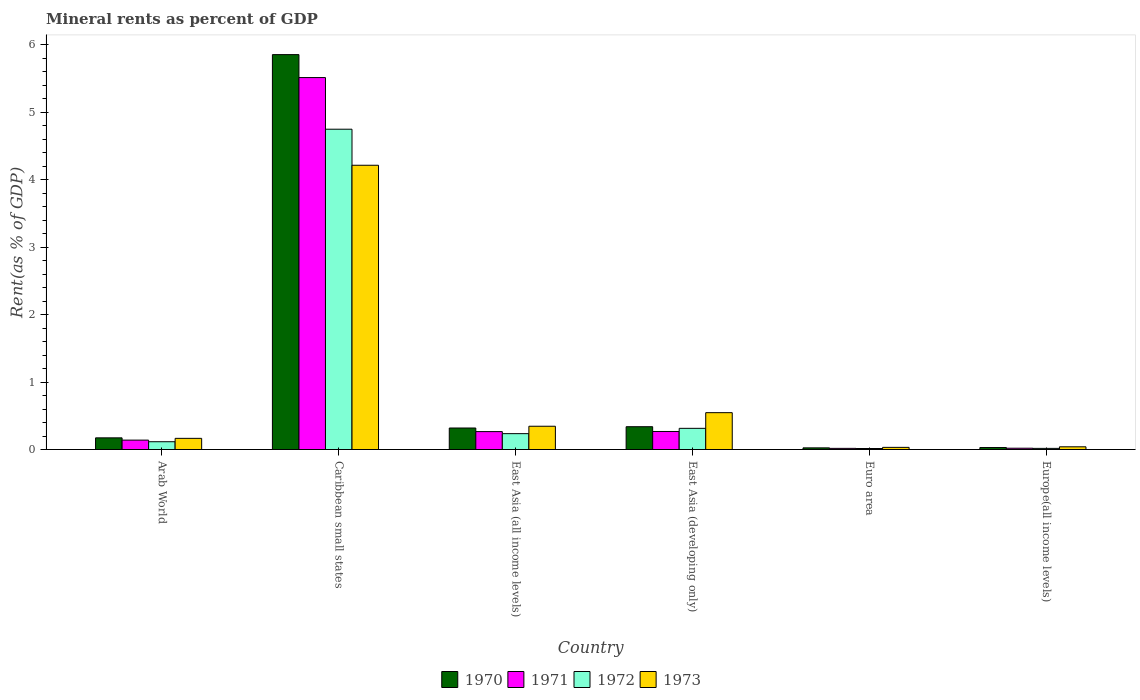Are the number of bars per tick equal to the number of legend labels?
Offer a very short reply. Yes. How many bars are there on the 2nd tick from the right?
Offer a very short reply. 4. What is the label of the 2nd group of bars from the left?
Offer a very short reply. Caribbean small states. In how many cases, is the number of bars for a given country not equal to the number of legend labels?
Your answer should be compact. 0. What is the mineral rent in 1970 in East Asia (developing only)?
Provide a short and direct response. 0.34. Across all countries, what is the maximum mineral rent in 1970?
Ensure brevity in your answer.  5.86. Across all countries, what is the minimum mineral rent in 1973?
Provide a succinct answer. 0.03. In which country was the mineral rent in 1970 maximum?
Your answer should be compact. Caribbean small states. What is the total mineral rent in 1970 in the graph?
Ensure brevity in your answer.  6.74. What is the difference between the mineral rent in 1973 in East Asia (developing only) and that in Euro area?
Offer a terse response. 0.51. What is the difference between the mineral rent in 1973 in East Asia (all income levels) and the mineral rent in 1971 in Arab World?
Offer a very short reply. 0.21. What is the average mineral rent in 1970 per country?
Your answer should be very brief. 1.12. What is the difference between the mineral rent of/in 1971 and mineral rent of/in 1973 in Arab World?
Your response must be concise. -0.03. What is the ratio of the mineral rent in 1972 in Arab World to that in East Asia (developing only)?
Provide a succinct answer. 0.37. Is the mineral rent in 1971 in East Asia (all income levels) less than that in Euro area?
Provide a succinct answer. No. What is the difference between the highest and the second highest mineral rent in 1971?
Give a very brief answer. -5.25. What is the difference between the highest and the lowest mineral rent in 1972?
Provide a short and direct response. 4.74. In how many countries, is the mineral rent in 1973 greater than the average mineral rent in 1973 taken over all countries?
Make the answer very short. 1. Is the sum of the mineral rent in 1970 in Caribbean small states and East Asia (all income levels) greater than the maximum mineral rent in 1973 across all countries?
Make the answer very short. Yes. Is it the case that in every country, the sum of the mineral rent in 1972 and mineral rent in 1973 is greater than the sum of mineral rent in 1971 and mineral rent in 1970?
Offer a very short reply. No. What does the 1st bar from the left in Euro area represents?
Offer a terse response. 1970. Is it the case that in every country, the sum of the mineral rent in 1973 and mineral rent in 1970 is greater than the mineral rent in 1972?
Give a very brief answer. Yes. How many countries are there in the graph?
Keep it short and to the point. 6. What is the difference between two consecutive major ticks on the Y-axis?
Offer a terse response. 1. Does the graph contain grids?
Your answer should be very brief. No. How many legend labels are there?
Offer a very short reply. 4. What is the title of the graph?
Provide a succinct answer. Mineral rents as percent of GDP. Does "1971" appear as one of the legend labels in the graph?
Give a very brief answer. Yes. What is the label or title of the Y-axis?
Offer a very short reply. Rent(as % of GDP). What is the Rent(as % of GDP) in 1970 in Arab World?
Your answer should be compact. 0.17. What is the Rent(as % of GDP) in 1971 in Arab World?
Your response must be concise. 0.14. What is the Rent(as % of GDP) in 1972 in Arab World?
Keep it short and to the point. 0.12. What is the Rent(as % of GDP) in 1973 in Arab World?
Provide a succinct answer. 0.17. What is the Rent(as % of GDP) in 1970 in Caribbean small states?
Make the answer very short. 5.86. What is the Rent(as % of GDP) of 1971 in Caribbean small states?
Ensure brevity in your answer.  5.52. What is the Rent(as % of GDP) in 1972 in Caribbean small states?
Offer a terse response. 4.75. What is the Rent(as % of GDP) of 1973 in Caribbean small states?
Provide a short and direct response. 4.22. What is the Rent(as % of GDP) of 1970 in East Asia (all income levels)?
Your answer should be very brief. 0.32. What is the Rent(as % of GDP) of 1971 in East Asia (all income levels)?
Your answer should be very brief. 0.27. What is the Rent(as % of GDP) of 1972 in East Asia (all income levels)?
Make the answer very short. 0.24. What is the Rent(as % of GDP) in 1973 in East Asia (all income levels)?
Keep it short and to the point. 0.35. What is the Rent(as % of GDP) in 1970 in East Asia (developing only)?
Your answer should be compact. 0.34. What is the Rent(as % of GDP) of 1971 in East Asia (developing only)?
Provide a short and direct response. 0.27. What is the Rent(as % of GDP) of 1972 in East Asia (developing only)?
Provide a short and direct response. 0.31. What is the Rent(as % of GDP) of 1973 in East Asia (developing only)?
Ensure brevity in your answer.  0.55. What is the Rent(as % of GDP) in 1970 in Euro area?
Keep it short and to the point. 0.02. What is the Rent(as % of GDP) in 1971 in Euro area?
Make the answer very short. 0.02. What is the Rent(as % of GDP) in 1972 in Euro area?
Provide a succinct answer. 0.02. What is the Rent(as % of GDP) of 1973 in Euro area?
Offer a very short reply. 0.03. What is the Rent(as % of GDP) in 1970 in Europe(all income levels)?
Your response must be concise. 0.03. What is the Rent(as % of GDP) in 1971 in Europe(all income levels)?
Ensure brevity in your answer.  0.02. What is the Rent(as % of GDP) of 1972 in Europe(all income levels)?
Your answer should be compact. 0.02. What is the Rent(as % of GDP) in 1973 in Europe(all income levels)?
Provide a short and direct response. 0.04. Across all countries, what is the maximum Rent(as % of GDP) in 1970?
Keep it short and to the point. 5.86. Across all countries, what is the maximum Rent(as % of GDP) of 1971?
Keep it short and to the point. 5.52. Across all countries, what is the maximum Rent(as % of GDP) of 1972?
Your answer should be compact. 4.75. Across all countries, what is the maximum Rent(as % of GDP) of 1973?
Provide a short and direct response. 4.22. Across all countries, what is the minimum Rent(as % of GDP) of 1970?
Provide a short and direct response. 0.02. Across all countries, what is the minimum Rent(as % of GDP) in 1971?
Your answer should be compact. 0.02. Across all countries, what is the minimum Rent(as % of GDP) in 1972?
Offer a terse response. 0.02. Across all countries, what is the minimum Rent(as % of GDP) in 1973?
Your response must be concise. 0.03. What is the total Rent(as % of GDP) in 1970 in the graph?
Provide a short and direct response. 6.74. What is the total Rent(as % of GDP) in 1971 in the graph?
Ensure brevity in your answer.  6.23. What is the total Rent(as % of GDP) of 1972 in the graph?
Make the answer very short. 5.45. What is the total Rent(as % of GDP) in 1973 in the graph?
Offer a terse response. 5.35. What is the difference between the Rent(as % of GDP) in 1970 in Arab World and that in Caribbean small states?
Ensure brevity in your answer.  -5.68. What is the difference between the Rent(as % of GDP) in 1971 in Arab World and that in Caribbean small states?
Provide a short and direct response. -5.38. What is the difference between the Rent(as % of GDP) of 1972 in Arab World and that in Caribbean small states?
Keep it short and to the point. -4.63. What is the difference between the Rent(as % of GDP) in 1973 in Arab World and that in Caribbean small states?
Your answer should be very brief. -4.05. What is the difference between the Rent(as % of GDP) of 1970 in Arab World and that in East Asia (all income levels)?
Your answer should be very brief. -0.15. What is the difference between the Rent(as % of GDP) of 1971 in Arab World and that in East Asia (all income levels)?
Offer a terse response. -0.13. What is the difference between the Rent(as % of GDP) of 1972 in Arab World and that in East Asia (all income levels)?
Your response must be concise. -0.12. What is the difference between the Rent(as % of GDP) of 1973 in Arab World and that in East Asia (all income levels)?
Keep it short and to the point. -0.18. What is the difference between the Rent(as % of GDP) in 1970 in Arab World and that in East Asia (developing only)?
Offer a very short reply. -0.17. What is the difference between the Rent(as % of GDP) of 1971 in Arab World and that in East Asia (developing only)?
Ensure brevity in your answer.  -0.13. What is the difference between the Rent(as % of GDP) in 1972 in Arab World and that in East Asia (developing only)?
Provide a short and direct response. -0.2. What is the difference between the Rent(as % of GDP) of 1973 in Arab World and that in East Asia (developing only)?
Provide a short and direct response. -0.38. What is the difference between the Rent(as % of GDP) of 1970 in Arab World and that in Euro area?
Keep it short and to the point. 0.15. What is the difference between the Rent(as % of GDP) of 1971 in Arab World and that in Euro area?
Keep it short and to the point. 0.12. What is the difference between the Rent(as % of GDP) in 1972 in Arab World and that in Euro area?
Keep it short and to the point. 0.1. What is the difference between the Rent(as % of GDP) of 1973 in Arab World and that in Euro area?
Ensure brevity in your answer.  0.13. What is the difference between the Rent(as % of GDP) of 1970 in Arab World and that in Europe(all income levels)?
Your answer should be compact. 0.14. What is the difference between the Rent(as % of GDP) in 1971 in Arab World and that in Europe(all income levels)?
Your answer should be very brief. 0.12. What is the difference between the Rent(as % of GDP) of 1972 in Arab World and that in Europe(all income levels)?
Ensure brevity in your answer.  0.1. What is the difference between the Rent(as % of GDP) of 1973 in Arab World and that in Europe(all income levels)?
Ensure brevity in your answer.  0.13. What is the difference between the Rent(as % of GDP) of 1970 in Caribbean small states and that in East Asia (all income levels)?
Offer a very short reply. 5.54. What is the difference between the Rent(as % of GDP) in 1971 in Caribbean small states and that in East Asia (all income levels)?
Provide a short and direct response. 5.25. What is the difference between the Rent(as % of GDP) in 1972 in Caribbean small states and that in East Asia (all income levels)?
Offer a very short reply. 4.51. What is the difference between the Rent(as % of GDP) in 1973 in Caribbean small states and that in East Asia (all income levels)?
Ensure brevity in your answer.  3.87. What is the difference between the Rent(as % of GDP) in 1970 in Caribbean small states and that in East Asia (developing only)?
Provide a short and direct response. 5.52. What is the difference between the Rent(as % of GDP) in 1971 in Caribbean small states and that in East Asia (developing only)?
Your answer should be compact. 5.25. What is the difference between the Rent(as % of GDP) in 1972 in Caribbean small states and that in East Asia (developing only)?
Your answer should be very brief. 4.44. What is the difference between the Rent(as % of GDP) in 1973 in Caribbean small states and that in East Asia (developing only)?
Your response must be concise. 3.67. What is the difference between the Rent(as % of GDP) of 1970 in Caribbean small states and that in Euro area?
Provide a succinct answer. 5.83. What is the difference between the Rent(as % of GDP) of 1971 in Caribbean small states and that in Euro area?
Keep it short and to the point. 5.5. What is the difference between the Rent(as % of GDP) of 1972 in Caribbean small states and that in Euro area?
Offer a terse response. 4.74. What is the difference between the Rent(as % of GDP) of 1973 in Caribbean small states and that in Euro area?
Your response must be concise. 4.18. What is the difference between the Rent(as % of GDP) of 1970 in Caribbean small states and that in Europe(all income levels)?
Keep it short and to the point. 5.83. What is the difference between the Rent(as % of GDP) in 1971 in Caribbean small states and that in Europe(all income levels)?
Your response must be concise. 5.5. What is the difference between the Rent(as % of GDP) in 1972 in Caribbean small states and that in Europe(all income levels)?
Make the answer very short. 4.73. What is the difference between the Rent(as % of GDP) in 1973 in Caribbean small states and that in Europe(all income levels)?
Give a very brief answer. 4.18. What is the difference between the Rent(as % of GDP) in 1970 in East Asia (all income levels) and that in East Asia (developing only)?
Make the answer very short. -0.02. What is the difference between the Rent(as % of GDP) of 1971 in East Asia (all income levels) and that in East Asia (developing only)?
Your response must be concise. -0. What is the difference between the Rent(as % of GDP) of 1972 in East Asia (all income levels) and that in East Asia (developing only)?
Provide a short and direct response. -0.08. What is the difference between the Rent(as % of GDP) in 1973 in East Asia (all income levels) and that in East Asia (developing only)?
Ensure brevity in your answer.  -0.2. What is the difference between the Rent(as % of GDP) in 1970 in East Asia (all income levels) and that in Euro area?
Make the answer very short. 0.29. What is the difference between the Rent(as % of GDP) in 1971 in East Asia (all income levels) and that in Euro area?
Make the answer very short. 0.25. What is the difference between the Rent(as % of GDP) in 1972 in East Asia (all income levels) and that in Euro area?
Make the answer very short. 0.22. What is the difference between the Rent(as % of GDP) in 1973 in East Asia (all income levels) and that in Euro area?
Ensure brevity in your answer.  0.31. What is the difference between the Rent(as % of GDP) of 1970 in East Asia (all income levels) and that in Europe(all income levels)?
Your answer should be compact. 0.29. What is the difference between the Rent(as % of GDP) in 1971 in East Asia (all income levels) and that in Europe(all income levels)?
Your answer should be compact. 0.25. What is the difference between the Rent(as % of GDP) of 1972 in East Asia (all income levels) and that in Europe(all income levels)?
Offer a terse response. 0.22. What is the difference between the Rent(as % of GDP) of 1973 in East Asia (all income levels) and that in Europe(all income levels)?
Offer a terse response. 0.3. What is the difference between the Rent(as % of GDP) of 1970 in East Asia (developing only) and that in Euro area?
Provide a succinct answer. 0.31. What is the difference between the Rent(as % of GDP) of 1971 in East Asia (developing only) and that in Euro area?
Ensure brevity in your answer.  0.25. What is the difference between the Rent(as % of GDP) of 1972 in East Asia (developing only) and that in Euro area?
Make the answer very short. 0.3. What is the difference between the Rent(as % of GDP) in 1973 in East Asia (developing only) and that in Euro area?
Offer a very short reply. 0.51. What is the difference between the Rent(as % of GDP) of 1970 in East Asia (developing only) and that in Europe(all income levels)?
Offer a very short reply. 0.31. What is the difference between the Rent(as % of GDP) in 1971 in East Asia (developing only) and that in Europe(all income levels)?
Keep it short and to the point. 0.25. What is the difference between the Rent(as % of GDP) in 1972 in East Asia (developing only) and that in Europe(all income levels)?
Ensure brevity in your answer.  0.3. What is the difference between the Rent(as % of GDP) in 1973 in East Asia (developing only) and that in Europe(all income levels)?
Make the answer very short. 0.51. What is the difference between the Rent(as % of GDP) of 1970 in Euro area and that in Europe(all income levels)?
Offer a terse response. -0. What is the difference between the Rent(as % of GDP) in 1971 in Euro area and that in Europe(all income levels)?
Give a very brief answer. -0. What is the difference between the Rent(as % of GDP) of 1972 in Euro area and that in Europe(all income levels)?
Give a very brief answer. -0. What is the difference between the Rent(as % of GDP) in 1973 in Euro area and that in Europe(all income levels)?
Ensure brevity in your answer.  -0.01. What is the difference between the Rent(as % of GDP) in 1970 in Arab World and the Rent(as % of GDP) in 1971 in Caribbean small states?
Provide a succinct answer. -5.34. What is the difference between the Rent(as % of GDP) in 1970 in Arab World and the Rent(as % of GDP) in 1972 in Caribbean small states?
Give a very brief answer. -4.58. What is the difference between the Rent(as % of GDP) in 1970 in Arab World and the Rent(as % of GDP) in 1973 in Caribbean small states?
Offer a terse response. -4.04. What is the difference between the Rent(as % of GDP) of 1971 in Arab World and the Rent(as % of GDP) of 1972 in Caribbean small states?
Offer a very short reply. -4.61. What is the difference between the Rent(as % of GDP) in 1971 in Arab World and the Rent(as % of GDP) in 1973 in Caribbean small states?
Offer a very short reply. -4.08. What is the difference between the Rent(as % of GDP) of 1972 in Arab World and the Rent(as % of GDP) of 1973 in Caribbean small states?
Your answer should be very brief. -4.1. What is the difference between the Rent(as % of GDP) of 1970 in Arab World and the Rent(as % of GDP) of 1971 in East Asia (all income levels)?
Provide a succinct answer. -0.09. What is the difference between the Rent(as % of GDP) of 1970 in Arab World and the Rent(as % of GDP) of 1972 in East Asia (all income levels)?
Give a very brief answer. -0.06. What is the difference between the Rent(as % of GDP) in 1970 in Arab World and the Rent(as % of GDP) in 1973 in East Asia (all income levels)?
Give a very brief answer. -0.17. What is the difference between the Rent(as % of GDP) of 1971 in Arab World and the Rent(as % of GDP) of 1972 in East Asia (all income levels)?
Your response must be concise. -0.1. What is the difference between the Rent(as % of GDP) in 1971 in Arab World and the Rent(as % of GDP) in 1973 in East Asia (all income levels)?
Offer a very short reply. -0.21. What is the difference between the Rent(as % of GDP) in 1972 in Arab World and the Rent(as % of GDP) in 1973 in East Asia (all income levels)?
Offer a very short reply. -0.23. What is the difference between the Rent(as % of GDP) of 1970 in Arab World and the Rent(as % of GDP) of 1971 in East Asia (developing only)?
Your response must be concise. -0.09. What is the difference between the Rent(as % of GDP) of 1970 in Arab World and the Rent(as % of GDP) of 1972 in East Asia (developing only)?
Provide a short and direct response. -0.14. What is the difference between the Rent(as % of GDP) in 1970 in Arab World and the Rent(as % of GDP) in 1973 in East Asia (developing only)?
Your response must be concise. -0.37. What is the difference between the Rent(as % of GDP) of 1971 in Arab World and the Rent(as % of GDP) of 1972 in East Asia (developing only)?
Offer a terse response. -0.17. What is the difference between the Rent(as % of GDP) in 1971 in Arab World and the Rent(as % of GDP) in 1973 in East Asia (developing only)?
Ensure brevity in your answer.  -0.41. What is the difference between the Rent(as % of GDP) in 1972 in Arab World and the Rent(as % of GDP) in 1973 in East Asia (developing only)?
Offer a terse response. -0.43. What is the difference between the Rent(as % of GDP) in 1970 in Arab World and the Rent(as % of GDP) in 1971 in Euro area?
Offer a terse response. 0.16. What is the difference between the Rent(as % of GDP) in 1970 in Arab World and the Rent(as % of GDP) in 1972 in Euro area?
Offer a terse response. 0.16. What is the difference between the Rent(as % of GDP) in 1970 in Arab World and the Rent(as % of GDP) in 1973 in Euro area?
Give a very brief answer. 0.14. What is the difference between the Rent(as % of GDP) in 1971 in Arab World and the Rent(as % of GDP) in 1972 in Euro area?
Offer a very short reply. 0.12. What is the difference between the Rent(as % of GDP) in 1971 in Arab World and the Rent(as % of GDP) in 1973 in Euro area?
Keep it short and to the point. 0.11. What is the difference between the Rent(as % of GDP) of 1972 in Arab World and the Rent(as % of GDP) of 1973 in Euro area?
Make the answer very short. 0.08. What is the difference between the Rent(as % of GDP) of 1970 in Arab World and the Rent(as % of GDP) of 1971 in Europe(all income levels)?
Give a very brief answer. 0.15. What is the difference between the Rent(as % of GDP) of 1970 in Arab World and the Rent(as % of GDP) of 1972 in Europe(all income levels)?
Ensure brevity in your answer.  0.16. What is the difference between the Rent(as % of GDP) in 1970 in Arab World and the Rent(as % of GDP) in 1973 in Europe(all income levels)?
Keep it short and to the point. 0.13. What is the difference between the Rent(as % of GDP) in 1971 in Arab World and the Rent(as % of GDP) in 1972 in Europe(all income levels)?
Keep it short and to the point. 0.12. What is the difference between the Rent(as % of GDP) in 1971 in Arab World and the Rent(as % of GDP) in 1973 in Europe(all income levels)?
Ensure brevity in your answer.  0.1. What is the difference between the Rent(as % of GDP) of 1972 in Arab World and the Rent(as % of GDP) of 1973 in Europe(all income levels)?
Keep it short and to the point. 0.08. What is the difference between the Rent(as % of GDP) of 1970 in Caribbean small states and the Rent(as % of GDP) of 1971 in East Asia (all income levels)?
Your response must be concise. 5.59. What is the difference between the Rent(as % of GDP) of 1970 in Caribbean small states and the Rent(as % of GDP) of 1972 in East Asia (all income levels)?
Your response must be concise. 5.62. What is the difference between the Rent(as % of GDP) of 1970 in Caribbean small states and the Rent(as % of GDP) of 1973 in East Asia (all income levels)?
Keep it short and to the point. 5.51. What is the difference between the Rent(as % of GDP) in 1971 in Caribbean small states and the Rent(as % of GDP) in 1972 in East Asia (all income levels)?
Offer a very short reply. 5.28. What is the difference between the Rent(as % of GDP) of 1971 in Caribbean small states and the Rent(as % of GDP) of 1973 in East Asia (all income levels)?
Give a very brief answer. 5.17. What is the difference between the Rent(as % of GDP) in 1972 in Caribbean small states and the Rent(as % of GDP) in 1973 in East Asia (all income levels)?
Keep it short and to the point. 4.41. What is the difference between the Rent(as % of GDP) of 1970 in Caribbean small states and the Rent(as % of GDP) of 1971 in East Asia (developing only)?
Your response must be concise. 5.59. What is the difference between the Rent(as % of GDP) in 1970 in Caribbean small states and the Rent(as % of GDP) in 1972 in East Asia (developing only)?
Provide a succinct answer. 5.54. What is the difference between the Rent(as % of GDP) in 1970 in Caribbean small states and the Rent(as % of GDP) in 1973 in East Asia (developing only)?
Provide a short and direct response. 5.31. What is the difference between the Rent(as % of GDP) of 1971 in Caribbean small states and the Rent(as % of GDP) of 1972 in East Asia (developing only)?
Your answer should be compact. 5.2. What is the difference between the Rent(as % of GDP) in 1971 in Caribbean small states and the Rent(as % of GDP) in 1973 in East Asia (developing only)?
Offer a very short reply. 4.97. What is the difference between the Rent(as % of GDP) of 1972 in Caribbean small states and the Rent(as % of GDP) of 1973 in East Asia (developing only)?
Offer a terse response. 4.2. What is the difference between the Rent(as % of GDP) of 1970 in Caribbean small states and the Rent(as % of GDP) of 1971 in Euro area?
Ensure brevity in your answer.  5.84. What is the difference between the Rent(as % of GDP) in 1970 in Caribbean small states and the Rent(as % of GDP) in 1972 in Euro area?
Your answer should be compact. 5.84. What is the difference between the Rent(as % of GDP) in 1970 in Caribbean small states and the Rent(as % of GDP) in 1973 in Euro area?
Make the answer very short. 5.82. What is the difference between the Rent(as % of GDP) of 1971 in Caribbean small states and the Rent(as % of GDP) of 1972 in Euro area?
Ensure brevity in your answer.  5.5. What is the difference between the Rent(as % of GDP) of 1971 in Caribbean small states and the Rent(as % of GDP) of 1973 in Euro area?
Offer a terse response. 5.48. What is the difference between the Rent(as % of GDP) in 1972 in Caribbean small states and the Rent(as % of GDP) in 1973 in Euro area?
Your answer should be very brief. 4.72. What is the difference between the Rent(as % of GDP) of 1970 in Caribbean small states and the Rent(as % of GDP) of 1971 in Europe(all income levels)?
Make the answer very short. 5.84. What is the difference between the Rent(as % of GDP) in 1970 in Caribbean small states and the Rent(as % of GDP) in 1972 in Europe(all income levels)?
Offer a terse response. 5.84. What is the difference between the Rent(as % of GDP) in 1970 in Caribbean small states and the Rent(as % of GDP) in 1973 in Europe(all income levels)?
Provide a short and direct response. 5.82. What is the difference between the Rent(as % of GDP) in 1971 in Caribbean small states and the Rent(as % of GDP) in 1972 in Europe(all income levels)?
Offer a terse response. 5.5. What is the difference between the Rent(as % of GDP) of 1971 in Caribbean small states and the Rent(as % of GDP) of 1973 in Europe(all income levels)?
Offer a terse response. 5.48. What is the difference between the Rent(as % of GDP) in 1972 in Caribbean small states and the Rent(as % of GDP) in 1973 in Europe(all income levels)?
Your response must be concise. 4.71. What is the difference between the Rent(as % of GDP) of 1970 in East Asia (all income levels) and the Rent(as % of GDP) of 1971 in East Asia (developing only)?
Provide a short and direct response. 0.05. What is the difference between the Rent(as % of GDP) in 1970 in East Asia (all income levels) and the Rent(as % of GDP) in 1972 in East Asia (developing only)?
Keep it short and to the point. 0. What is the difference between the Rent(as % of GDP) in 1970 in East Asia (all income levels) and the Rent(as % of GDP) in 1973 in East Asia (developing only)?
Make the answer very short. -0.23. What is the difference between the Rent(as % of GDP) of 1971 in East Asia (all income levels) and the Rent(as % of GDP) of 1972 in East Asia (developing only)?
Your answer should be very brief. -0.05. What is the difference between the Rent(as % of GDP) in 1971 in East Asia (all income levels) and the Rent(as % of GDP) in 1973 in East Asia (developing only)?
Provide a short and direct response. -0.28. What is the difference between the Rent(as % of GDP) of 1972 in East Asia (all income levels) and the Rent(as % of GDP) of 1973 in East Asia (developing only)?
Keep it short and to the point. -0.31. What is the difference between the Rent(as % of GDP) in 1970 in East Asia (all income levels) and the Rent(as % of GDP) in 1971 in Euro area?
Give a very brief answer. 0.3. What is the difference between the Rent(as % of GDP) in 1970 in East Asia (all income levels) and the Rent(as % of GDP) in 1972 in Euro area?
Ensure brevity in your answer.  0.3. What is the difference between the Rent(as % of GDP) of 1970 in East Asia (all income levels) and the Rent(as % of GDP) of 1973 in Euro area?
Make the answer very short. 0.29. What is the difference between the Rent(as % of GDP) of 1971 in East Asia (all income levels) and the Rent(as % of GDP) of 1972 in Euro area?
Offer a very short reply. 0.25. What is the difference between the Rent(as % of GDP) in 1971 in East Asia (all income levels) and the Rent(as % of GDP) in 1973 in Euro area?
Provide a short and direct response. 0.23. What is the difference between the Rent(as % of GDP) of 1972 in East Asia (all income levels) and the Rent(as % of GDP) of 1973 in Euro area?
Provide a short and direct response. 0.2. What is the difference between the Rent(as % of GDP) of 1970 in East Asia (all income levels) and the Rent(as % of GDP) of 1971 in Europe(all income levels)?
Provide a succinct answer. 0.3. What is the difference between the Rent(as % of GDP) of 1970 in East Asia (all income levels) and the Rent(as % of GDP) of 1972 in Europe(all income levels)?
Provide a succinct answer. 0.3. What is the difference between the Rent(as % of GDP) in 1970 in East Asia (all income levels) and the Rent(as % of GDP) in 1973 in Europe(all income levels)?
Your answer should be compact. 0.28. What is the difference between the Rent(as % of GDP) in 1971 in East Asia (all income levels) and the Rent(as % of GDP) in 1972 in Europe(all income levels)?
Provide a succinct answer. 0.25. What is the difference between the Rent(as % of GDP) in 1971 in East Asia (all income levels) and the Rent(as % of GDP) in 1973 in Europe(all income levels)?
Your answer should be compact. 0.23. What is the difference between the Rent(as % of GDP) in 1972 in East Asia (all income levels) and the Rent(as % of GDP) in 1973 in Europe(all income levels)?
Your answer should be very brief. 0.2. What is the difference between the Rent(as % of GDP) in 1970 in East Asia (developing only) and the Rent(as % of GDP) in 1971 in Euro area?
Offer a terse response. 0.32. What is the difference between the Rent(as % of GDP) of 1970 in East Asia (developing only) and the Rent(as % of GDP) of 1972 in Euro area?
Your answer should be compact. 0.32. What is the difference between the Rent(as % of GDP) in 1970 in East Asia (developing only) and the Rent(as % of GDP) in 1973 in Euro area?
Your answer should be compact. 0.31. What is the difference between the Rent(as % of GDP) in 1971 in East Asia (developing only) and the Rent(as % of GDP) in 1972 in Euro area?
Your answer should be compact. 0.25. What is the difference between the Rent(as % of GDP) of 1971 in East Asia (developing only) and the Rent(as % of GDP) of 1973 in Euro area?
Your answer should be compact. 0.24. What is the difference between the Rent(as % of GDP) of 1972 in East Asia (developing only) and the Rent(as % of GDP) of 1973 in Euro area?
Your answer should be compact. 0.28. What is the difference between the Rent(as % of GDP) in 1970 in East Asia (developing only) and the Rent(as % of GDP) in 1971 in Europe(all income levels)?
Offer a very short reply. 0.32. What is the difference between the Rent(as % of GDP) of 1970 in East Asia (developing only) and the Rent(as % of GDP) of 1972 in Europe(all income levels)?
Keep it short and to the point. 0.32. What is the difference between the Rent(as % of GDP) in 1970 in East Asia (developing only) and the Rent(as % of GDP) in 1973 in Europe(all income levels)?
Your response must be concise. 0.3. What is the difference between the Rent(as % of GDP) of 1971 in East Asia (developing only) and the Rent(as % of GDP) of 1972 in Europe(all income levels)?
Keep it short and to the point. 0.25. What is the difference between the Rent(as % of GDP) of 1971 in East Asia (developing only) and the Rent(as % of GDP) of 1973 in Europe(all income levels)?
Offer a terse response. 0.23. What is the difference between the Rent(as % of GDP) in 1972 in East Asia (developing only) and the Rent(as % of GDP) in 1973 in Europe(all income levels)?
Give a very brief answer. 0.27. What is the difference between the Rent(as % of GDP) in 1970 in Euro area and the Rent(as % of GDP) in 1971 in Europe(all income levels)?
Give a very brief answer. 0.01. What is the difference between the Rent(as % of GDP) of 1970 in Euro area and the Rent(as % of GDP) of 1972 in Europe(all income levels)?
Make the answer very short. 0.01. What is the difference between the Rent(as % of GDP) in 1970 in Euro area and the Rent(as % of GDP) in 1973 in Europe(all income levels)?
Keep it short and to the point. -0.02. What is the difference between the Rent(as % of GDP) of 1971 in Euro area and the Rent(as % of GDP) of 1973 in Europe(all income levels)?
Provide a succinct answer. -0.02. What is the difference between the Rent(as % of GDP) in 1972 in Euro area and the Rent(as % of GDP) in 1973 in Europe(all income levels)?
Give a very brief answer. -0.03. What is the average Rent(as % of GDP) of 1970 per country?
Keep it short and to the point. 1.12. What is the average Rent(as % of GDP) in 1971 per country?
Your answer should be very brief. 1.04. What is the average Rent(as % of GDP) of 1972 per country?
Your answer should be very brief. 0.91. What is the average Rent(as % of GDP) of 1973 per country?
Make the answer very short. 0.89. What is the difference between the Rent(as % of GDP) in 1970 and Rent(as % of GDP) in 1971 in Arab World?
Keep it short and to the point. 0.03. What is the difference between the Rent(as % of GDP) of 1970 and Rent(as % of GDP) of 1972 in Arab World?
Offer a very short reply. 0.06. What is the difference between the Rent(as % of GDP) of 1970 and Rent(as % of GDP) of 1973 in Arab World?
Your answer should be compact. 0.01. What is the difference between the Rent(as % of GDP) in 1971 and Rent(as % of GDP) in 1972 in Arab World?
Offer a terse response. 0.02. What is the difference between the Rent(as % of GDP) in 1971 and Rent(as % of GDP) in 1973 in Arab World?
Provide a short and direct response. -0.03. What is the difference between the Rent(as % of GDP) of 1972 and Rent(as % of GDP) of 1973 in Arab World?
Offer a very short reply. -0.05. What is the difference between the Rent(as % of GDP) of 1970 and Rent(as % of GDP) of 1971 in Caribbean small states?
Offer a terse response. 0.34. What is the difference between the Rent(as % of GDP) in 1970 and Rent(as % of GDP) in 1972 in Caribbean small states?
Provide a short and direct response. 1.11. What is the difference between the Rent(as % of GDP) of 1970 and Rent(as % of GDP) of 1973 in Caribbean small states?
Give a very brief answer. 1.64. What is the difference between the Rent(as % of GDP) of 1971 and Rent(as % of GDP) of 1972 in Caribbean small states?
Your answer should be compact. 0.77. What is the difference between the Rent(as % of GDP) of 1971 and Rent(as % of GDP) of 1973 in Caribbean small states?
Your answer should be compact. 1.3. What is the difference between the Rent(as % of GDP) in 1972 and Rent(as % of GDP) in 1973 in Caribbean small states?
Your response must be concise. 0.53. What is the difference between the Rent(as % of GDP) of 1970 and Rent(as % of GDP) of 1971 in East Asia (all income levels)?
Give a very brief answer. 0.05. What is the difference between the Rent(as % of GDP) in 1970 and Rent(as % of GDP) in 1972 in East Asia (all income levels)?
Ensure brevity in your answer.  0.08. What is the difference between the Rent(as % of GDP) of 1970 and Rent(as % of GDP) of 1973 in East Asia (all income levels)?
Provide a short and direct response. -0.03. What is the difference between the Rent(as % of GDP) of 1971 and Rent(as % of GDP) of 1972 in East Asia (all income levels)?
Offer a very short reply. 0.03. What is the difference between the Rent(as % of GDP) in 1971 and Rent(as % of GDP) in 1973 in East Asia (all income levels)?
Make the answer very short. -0.08. What is the difference between the Rent(as % of GDP) of 1972 and Rent(as % of GDP) of 1973 in East Asia (all income levels)?
Keep it short and to the point. -0.11. What is the difference between the Rent(as % of GDP) of 1970 and Rent(as % of GDP) of 1971 in East Asia (developing only)?
Keep it short and to the point. 0.07. What is the difference between the Rent(as % of GDP) of 1970 and Rent(as % of GDP) of 1972 in East Asia (developing only)?
Offer a terse response. 0.02. What is the difference between the Rent(as % of GDP) in 1970 and Rent(as % of GDP) in 1973 in East Asia (developing only)?
Offer a very short reply. -0.21. What is the difference between the Rent(as % of GDP) in 1971 and Rent(as % of GDP) in 1972 in East Asia (developing only)?
Keep it short and to the point. -0.05. What is the difference between the Rent(as % of GDP) in 1971 and Rent(as % of GDP) in 1973 in East Asia (developing only)?
Provide a short and direct response. -0.28. What is the difference between the Rent(as % of GDP) in 1972 and Rent(as % of GDP) in 1973 in East Asia (developing only)?
Provide a succinct answer. -0.23. What is the difference between the Rent(as % of GDP) of 1970 and Rent(as % of GDP) of 1971 in Euro area?
Your response must be concise. 0.01. What is the difference between the Rent(as % of GDP) in 1970 and Rent(as % of GDP) in 1972 in Euro area?
Ensure brevity in your answer.  0.01. What is the difference between the Rent(as % of GDP) of 1970 and Rent(as % of GDP) of 1973 in Euro area?
Keep it short and to the point. -0.01. What is the difference between the Rent(as % of GDP) of 1971 and Rent(as % of GDP) of 1972 in Euro area?
Offer a terse response. 0. What is the difference between the Rent(as % of GDP) of 1971 and Rent(as % of GDP) of 1973 in Euro area?
Offer a very short reply. -0.01. What is the difference between the Rent(as % of GDP) of 1972 and Rent(as % of GDP) of 1973 in Euro area?
Keep it short and to the point. -0.02. What is the difference between the Rent(as % of GDP) in 1970 and Rent(as % of GDP) in 1971 in Europe(all income levels)?
Your answer should be compact. 0.01. What is the difference between the Rent(as % of GDP) in 1970 and Rent(as % of GDP) in 1972 in Europe(all income levels)?
Offer a terse response. 0.01. What is the difference between the Rent(as % of GDP) of 1970 and Rent(as % of GDP) of 1973 in Europe(all income levels)?
Provide a short and direct response. -0.01. What is the difference between the Rent(as % of GDP) in 1971 and Rent(as % of GDP) in 1972 in Europe(all income levels)?
Make the answer very short. 0. What is the difference between the Rent(as % of GDP) in 1971 and Rent(as % of GDP) in 1973 in Europe(all income levels)?
Ensure brevity in your answer.  -0.02. What is the difference between the Rent(as % of GDP) in 1972 and Rent(as % of GDP) in 1973 in Europe(all income levels)?
Keep it short and to the point. -0.02. What is the ratio of the Rent(as % of GDP) of 1970 in Arab World to that in Caribbean small states?
Your answer should be compact. 0.03. What is the ratio of the Rent(as % of GDP) of 1971 in Arab World to that in Caribbean small states?
Ensure brevity in your answer.  0.03. What is the ratio of the Rent(as % of GDP) in 1972 in Arab World to that in Caribbean small states?
Your answer should be very brief. 0.02. What is the ratio of the Rent(as % of GDP) of 1973 in Arab World to that in Caribbean small states?
Your answer should be compact. 0.04. What is the ratio of the Rent(as % of GDP) of 1970 in Arab World to that in East Asia (all income levels)?
Your response must be concise. 0.54. What is the ratio of the Rent(as % of GDP) in 1971 in Arab World to that in East Asia (all income levels)?
Make the answer very short. 0.52. What is the ratio of the Rent(as % of GDP) of 1972 in Arab World to that in East Asia (all income levels)?
Make the answer very short. 0.49. What is the ratio of the Rent(as % of GDP) in 1973 in Arab World to that in East Asia (all income levels)?
Your response must be concise. 0.48. What is the ratio of the Rent(as % of GDP) in 1970 in Arab World to that in East Asia (developing only)?
Your answer should be compact. 0.51. What is the ratio of the Rent(as % of GDP) in 1971 in Arab World to that in East Asia (developing only)?
Your answer should be compact. 0.52. What is the ratio of the Rent(as % of GDP) of 1972 in Arab World to that in East Asia (developing only)?
Give a very brief answer. 0.37. What is the ratio of the Rent(as % of GDP) of 1973 in Arab World to that in East Asia (developing only)?
Ensure brevity in your answer.  0.3. What is the ratio of the Rent(as % of GDP) of 1970 in Arab World to that in Euro area?
Make the answer very short. 7.04. What is the ratio of the Rent(as % of GDP) in 1971 in Arab World to that in Euro area?
Your answer should be compact. 8.15. What is the ratio of the Rent(as % of GDP) in 1972 in Arab World to that in Euro area?
Keep it short and to the point. 7.69. What is the ratio of the Rent(as % of GDP) in 1973 in Arab World to that in Euro area?
Provide a succinct answer. 5.19. What is the ratio of the Rent(as % of GDP) in 1970 in Arab World to that in Europe(all income levels)?
Ensure brevity in your answer.  5.91. What is the ratio of the Rent(as % of GDP) of 1971 in Arab World to that in Europe(all income levels)?
Offer a terse response. 7.19. What is the ratio of the Rent(as % of GDP) in 1972 in Arab World to that in Europe(all income levels)?
Keep it short and to the point. 6.82. What is the ratio of the Rent(as % of GDP) in 1973 in Arab World to that in Europe(all income levels)?
Your response must be concise. 4.12. What is the ratio of the Rent(as % of GDP) of 1970 in Caribbean small states to that in East Asia (all income levels)?
Offer a very short reply. 18.36. What is the ratio of the Rent(as % of GDP) of 1971 in Caribbean small states to that in East Asia (all income levels)?
Ensure brevity in your answer.  20.76. What is the ratio of the Rent(as % of GDP) of 1972 in Caribbean small states to that in East Asia (all income levels)?
Provide a succinct answer. 20.18. What is the ratio of the Rent(as % of GDP) of 1973 in Caribbean small states to that in East Asia (all income levels)?
Make the answer very short. 12.21. What is the ratio of the Rent(as % of GDP) in 1970 in Caribbean small states to that in East Asia (developing only)?
Provide a succinct answer. 17.32. What is the ratio of the Rent(as % of GDP) in 1971 in Caribbean small states to that in East Asia (developing only)?
Provide a succinct answer. 20.61. What is the ratio of the Rent(as % of GDP) of 1972 in Caribbean small states to that in East Asia (developing only)?
Provide a short and direct response. 15.12. What is the ratio of the Rent(as % of GDP) of 1973 in Caribbean small states to that in East Asia (developing only)?
Give a very brief answer. 7.71. What is the ratio of the Rent(as % of GDP) in 1970 in Caribbean small states to that in Euro area?
Give a very brief answer. 238.3. What is the ratio of the Rent(as % of GDP) in 1971 in Caribbean small states to that in Euro area?
Provide a short and direct response. 322.45. What is the ratio of the Rent(as % of GDP) in 1972 in Caribbean small states to that in Euro area?
Your answer should be very brief. 316.05. What is the ratio of the Rent(as % of GDP) in 1973 in Caribbean small states to that in Euro area?
Make the answer very short. 132.23. What is the ratio of the Rent(as % of GDP) of 1970 in Caribbean small states to that in Europe(all income levels)?
Ensure brevity in your answer.  199.94. What is the ratio of the Rent(as % of GDP) of 1971 in Caribbean small states to that in Europe(all income levels)?
Give a very brief answer. 284.43. What is the ratio of the Rent(as % of GDP) of 1972 in Caribbean small states to that in Europe(all income levels)?
Provide a succinct answer. 279.99. What is the ratio of the Rent(as % of GDP) of 1973 in Caribbean small states to that in Europe(all income levels)?
Make the answer very short. 104.81. What is the ratio of the Rent(as % of GDP) of 1970 in East Asia (all income levels) to that in East Asia (developing only)?
Offer a very short reply. 0.94. What is the ratio of the Rent(as % of GDP) in 1971 in East Asia (all income levels) to that in East Asia (developing only)?
Ensure brevity in your answer.  0.99. What is the ratio of the Rent(as % of GDP) of 1972 in East Asia (all income levels) to that in East Asia (developing only)?
Give a very brief answer. 0.75. What is the ratio of the Rent(as % of GDP) in 1973 in East Asia (all income levels) to that in East Asia (developing only)?
Your response must be concise. 0.63. What is the ratio of the Rent(as % of GDP) in 1970 in East Asia (all income levels) to that in Euro area?
Provide a succinct answer. 12.98. What is the ratio of the Rent(as % of GDP) in 1971 in East Asia (all income levels) to that in Euro area?
Provide a short and direct response. 15.54. What is the ratio of the Rent(as % of GDP) in 1972 in East Asia (all income levels) to that in Euro area?
Provide a succinct answer. 15.66. What is the ratio of the Rent(as % of GDP) in 1973 in East Asia (all income levels) to that in Euro area?
Your response must be concise. 10.83. What is the ratio of the Rent(as % of GDP) of 1970 in East Asia (all income levels) to that in Europe(all income levels)?
Ensure brevity in your answer.  10.89. What is the ratio of the Rent(as % of GDP) in 1971 in East Asia (all income levels) to that in Europe(all income levels)?
Give a very brief answer. 13.7. What is the ratio of the Rent(as % of GDP) of 1972 in East Asia (all income levels) to that in Europe(all income levels)?
Ensure brevity in your answer.  13.88. What is the ratio of the Rent(as % of GDP) of 1973 in East Asia (all income levels) to that in Europe(all income levels)?
Your response must be concise. 8.58. What is the ratio of the Rent(as % of GDP) of 1970 in East Asia (developing only) to that in Euro area?
Offer a very short reply. 13.76. What is the ratio of the Rent(as % of GDP) of 1971 in East Asia (developing only) to that in Euro area?
Offer a very short reply. 15.65. What is the ratio of the Rent(as % of GDP) of 1972 in East Asia (developing only) to that in Euro area?
Ensure brevity in your answer.  20.91. What is the ratio of the Rent(as % of GDP) of 1973 in East Asia (developing only) to that in Euro area?
Provide a succinct answer. 17.14. What is the ratio of the Rent(as % of GDP) of 1970 in East Asia (developing only) to that in Europe(all income levels)?
Your answer should be compact. 11.55. What is the ratio of the Rent(as % of GDP) of 1971 in East Asia (developing only) to that in Europe(all income levels)?
Your response must be concise. 13.8. What is the ratio of the Rent(as % of GDP) in 1972 in East Asia (developing only) to that in Europe(all income levels)?
Provide a succinct answer. 18.52. What is the ratio of the Rent(as % of GDP) in 1973 in East Asia (developing only) to that in Europe(all income levels)?
Offer a very short reply. 13.59. What is the ratio of the Rent(as % of GDP) of 1970 in Euro area to that in Europe(all income levels)?
Provide a short and direct response. 0.84. What is the ratio of the Rent(as % of GDP) of 1971 in Euro area to that in Europe(all income levels)?
Provide a succinct answer. 0.88. What is the ratio of the Rent(as % of GDP) of 1972 in Euro area to that in Europe(all income levels)?
Offer a terse response. 0.89. What is the ratio of the Rent(as % of GDP) in 1973 in Euro area to that in Europe(all income levels)?
Your answer should be compact. 0.79. What is the difference between the highest and the second highest Rent(as % of GDP) of 1970?
Your response must be concise. 5.52. What is the difference between the highest and the second highest Rent(as % of GDP) of 1971?
Your response must be concise. 5.25. What is the difference between the highest and the second highest Rent(as % of GDP) in 1972?
Offer a terse response. 4.44. What is the difference between the highest and the second highest Rent(as % of GDP) in 1973?
Make the answer very short. 3.67. What is the difference between the highest and the lowest Rent(as % of GDP) of 1970?
Your answer should be very brief. 5.83. What is the difference between the highest and the lowest Rent(as % of GDP) in 1971?
Your answer should be very brief. 5.5. What is the difference between the highest and the lowest Rent(as % of GDP) in 1972?
Keep it short and to the point. 4.74. What is the difference between the highest and the lowest Rent(as % of GDP) of 1973?
Your response must be concise. 4.18. 